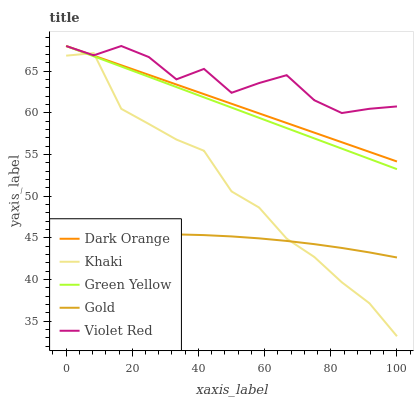Does Gold have the minimum area under the curve?
Answer yes or no. Yes. Does Violet Red have the maximum area under the curve?
Answer yes or no. Yes. Does Green Yellow have the minimum area under the curve?
Answer yes or no. No. Does Green Yellow have the maximum area under the curve?
Answer yes or no. No. Is Dark Orange the smoothest?
Answer yes or no. Yes. Is Violet Red the roughest?
Answer yes or no. Yes. Is Green Yellow the smoothest?
Answer yes or no. No. Is Green Yellow the roughest?
Answer yes or no. No. Does Khaki have the lowest value?
Answer yes or no. Yes. Does Green Yellow have the lowest value?
Answer yes or no. No. Does Violet Red have the highest value?
Answer yes or no. Yes. Does Khaki have the highest value?
Answer yes or no. No. Is Gold less than Green Yellow?
Answer yes or no. Yes. Is Green Yellow greater than Gold?
Answer yes or no. Yes. Does Green Yellow intersect Dark Orange?
Answer yes or no. Yes. Is Green Yellow less than Dark Orange?
Answer yes or no. No. Is Green Yellow greater than Dark Orange?
Answer yes or no. No. Does Gold intersect Green Yellow?
Answer yes or no. No. 